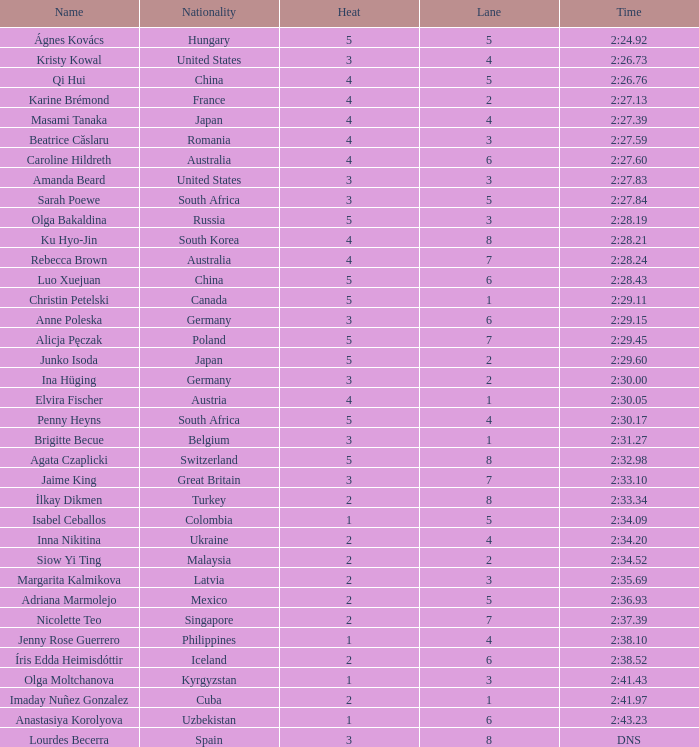What is the name that saw 4 heats and a lane higher than 7? Ku Hyo-Jin. 